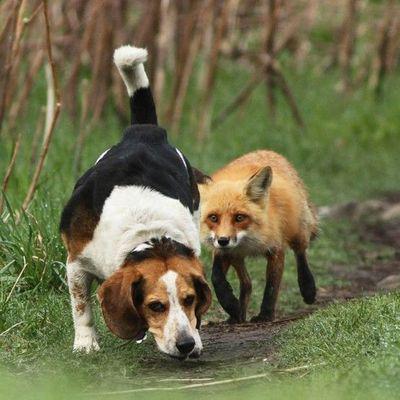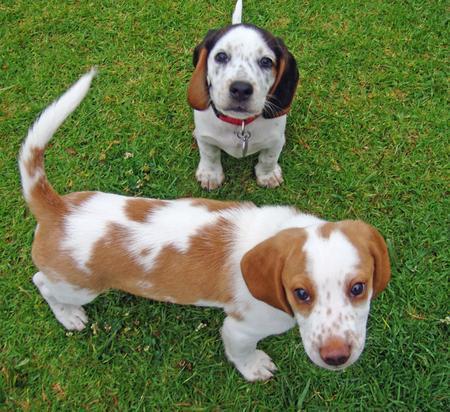The first image is the image on the left, the second image is the image on the right. For the images shown, is this caption "The left image contains at least three dogs." true? Answer yes or no. No. 